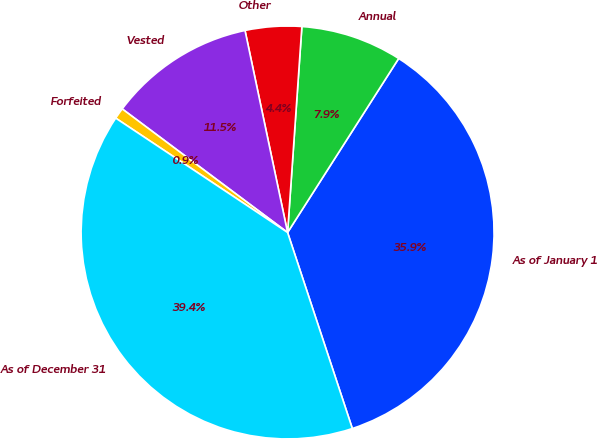Convert chart to OTSL. <chart><loc_0><loc_0><loc_500><loc_500><pie_chart><fcel>As of January 1<fcel>Annual<fcel>Other<fcel>Vested<fcel>Forfeited<fcel>As of December 31<nl><fcel>35.88%<fcel>7.94%<fcel>4.41%<fcel>11.48%<fcel>0.87%<fcel>39.42%<nl></chart> 